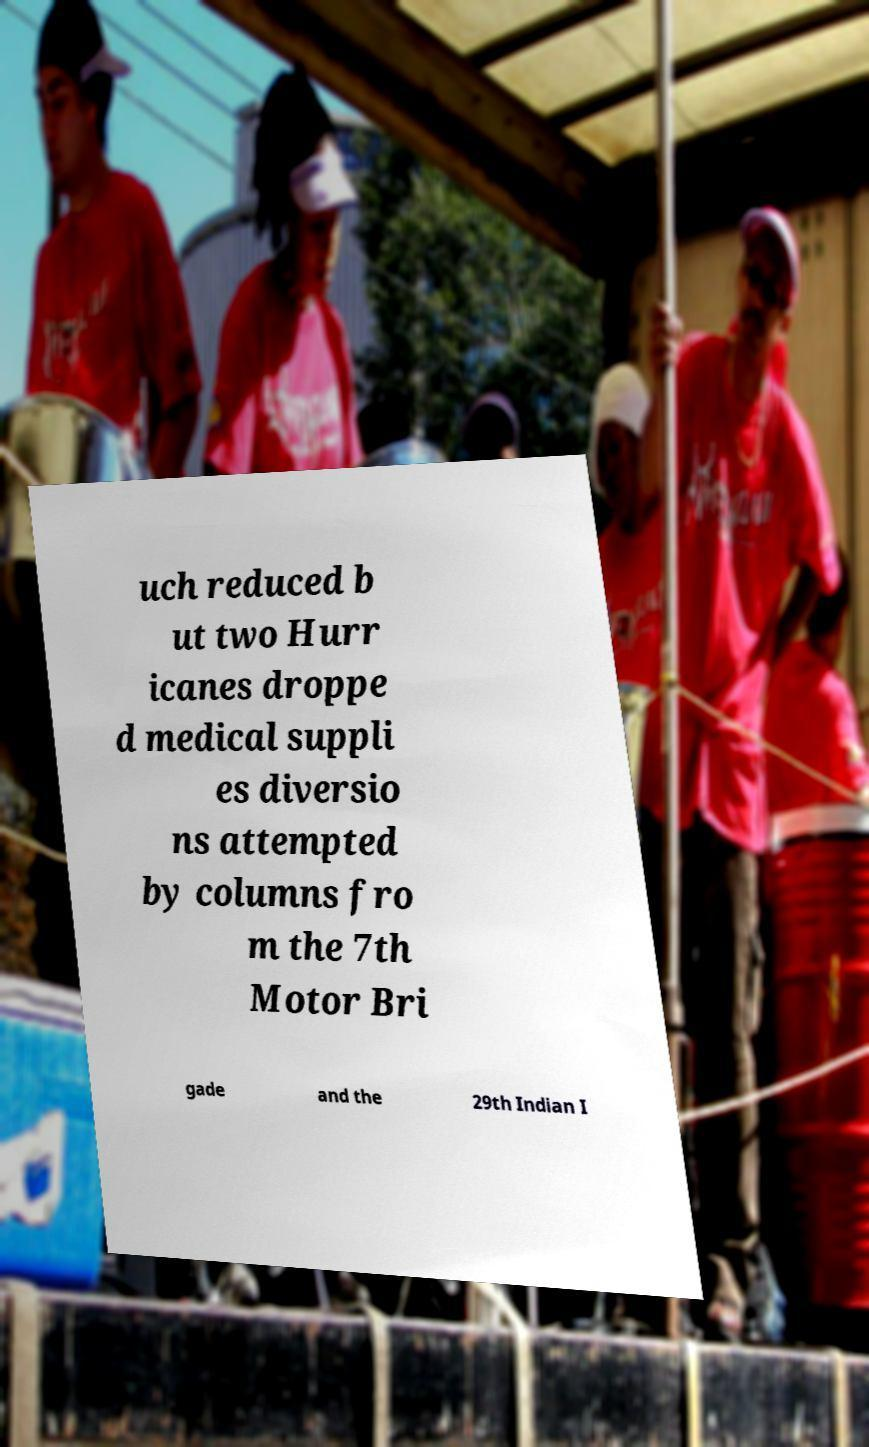For documentation purposes, I need the text within this image transcribed. Could you provide that? uch reduced b ut two Hurr icanes droppe d medical suppli es diversio ns attempted by columns fro m the 7th Motor Bri gade and the 29th Indian I 